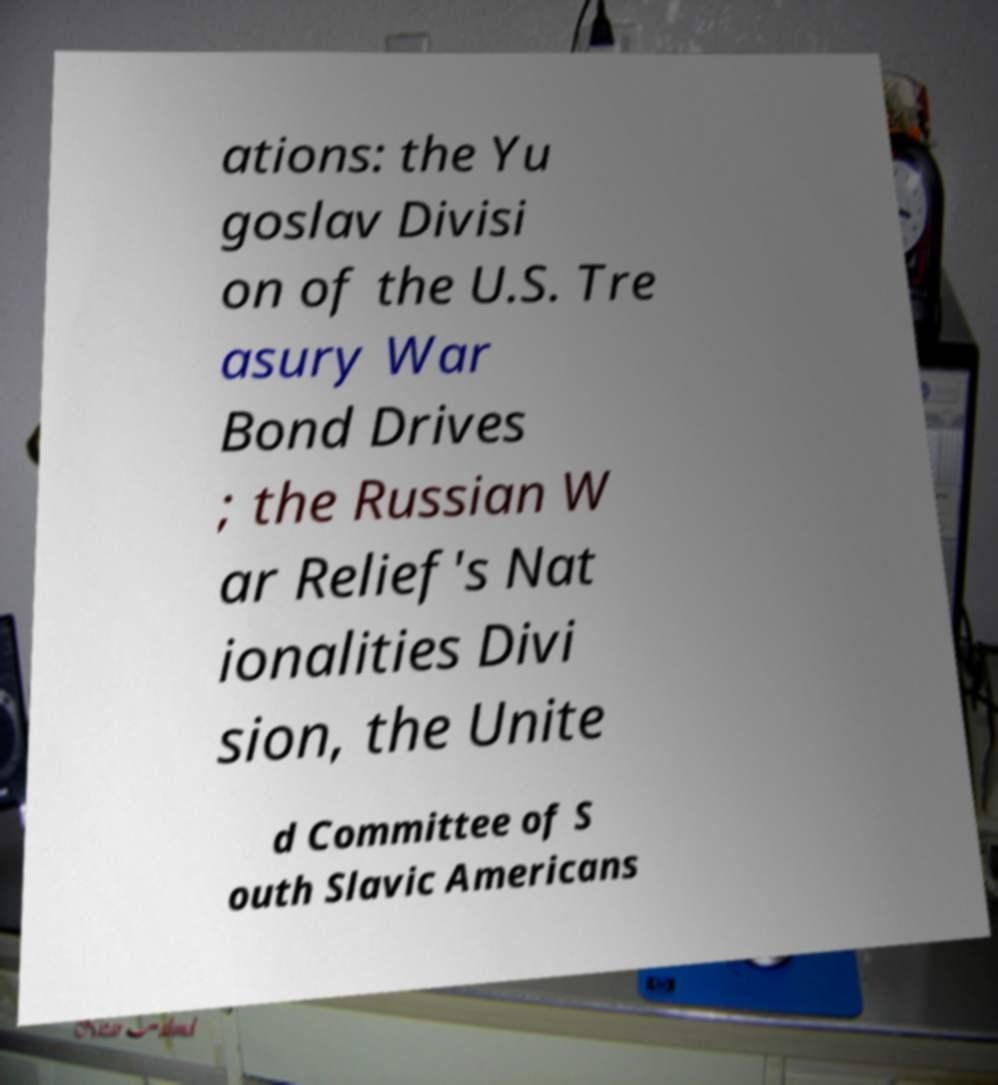Could you assist in decoding the text presented in this image and type it out clearly? ations: the Yu goslav Divisi on of the U.S. Tre asury War Bond Drives ; the Russian W ar Relief's Nat ionalities Divi sion, the Unite d Committee of S outh Slavic Americans 